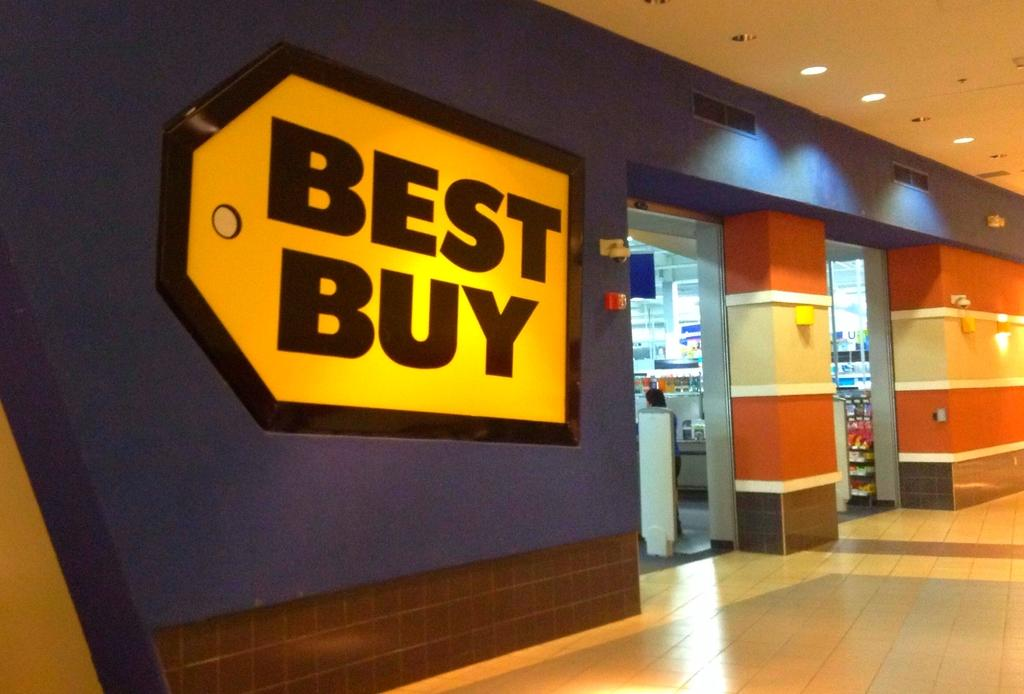What type of establishment is located in the middle of the image? There is a store in the middle of the image. What can be seen at the top of the image? There are lights at the top of the image. What is on the wall on the left side of the image? There is a hoarding on the wall on the left side of the image. How does the lawyer feel about the cup in the image? There is no lawyer or cup present in the image, so it is not possible to answer that question. 